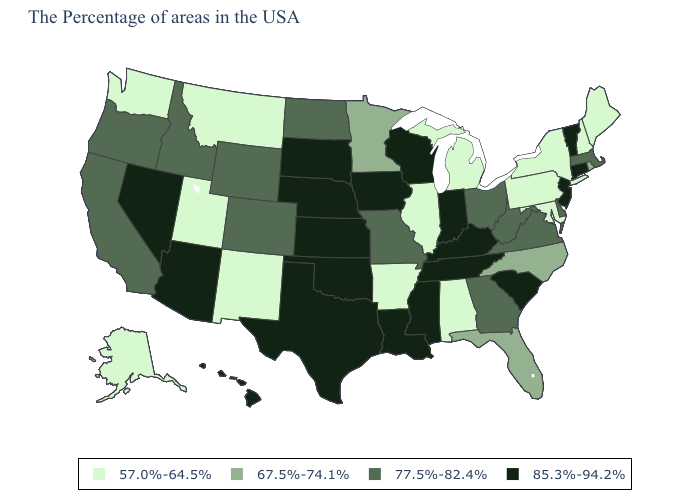What is the value of Vermont?
Concise answer only. 85.3%-94.2%. Which states have the lowest value in the USA?
Give a very brief answer. Maine, New Hampshire, New York, Maryland, Pennsylvania, Michigan, Alabama, Illinois, Arkansas, New Mexico, Utah, Montana, Washington, Alaska. Name the states that have a value in the range 67.5%-74.1%?
Concise answer only. Rhode Island, North Carolina, Florida, Minnesota. What is the value of Iowa?
Short answer required. 85.3%-94.2%. Does Montana have the lowest value in the USA?
Give a very brief answer. Yes. Which states have the highest value in the USA?
Concise answer only. Vermont, Connecticut, New Jersey, South Carolina, Kentucky, Indiana, Tennessee, Wisconsin, Mississippi, Louisiana, Iowa, Kansas, Nebraska, Oklahoma, Texas, South Dakota, Arizona, Nevada, Hawaii. Name the states that have a value in the range 67.5%-74.1%?
Short answer required. Rhode Island, North Carolina, Florida, Minnesota. Among the states that border Louisiana , which have the highest value?
Give a very brief answer. Mississippi, Texas. Among the states that border Texas , does Louisiana have the lowest value?
Concise answer only. No. What is the value of New Hampshire?
Concise answer only. 57.0%-64.5%. What is the value of Vermont?
Concise answer only. 85.3%-94.2%. Does Delaware have the highest value in the USA?
Keep it brief. No. Name the states that have a value in the range 85.3%-94.2%?
Write a very short answer. Vermont, Connecticut, New Jersey, South Carolina, Kentucky, Indiana, Tennessee, Wisconsin, Mississippi, Louisiana, Iowa, Kansas, Nebraska, Oklahoma, Texas, South Dakota, Arizona, Nevada, Hawaii. What is the value of Iowa?
Be succinct. 85.3%-94.2%. What is the lowest value in the MidWest?
Write a very short answer. 57.0%-64.5%. 